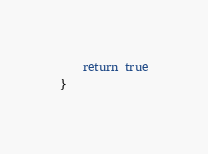Convert code to text. <code><loc_0><loc_0><loc_500><loc_500><_Kotlin_>    return true
}</code> 